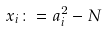<formula> <loc_0><loc_0><loc_500><loc_500>x _ { i } \colon = a _ { i } ^ { 2 } - N</formula> 